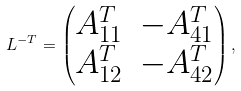Convert formula to latex. <formula><loc_0><loc_0><loc_500><loc_500>L ^ { - T } = \begin{pmatrix} A _ { 1 1 } ^ { T } & - A _ { 4 1 } ^ { T } \\ A _ { 1 2 } ^ { T } & - A _ { 4 2 } ^ { T } \end{pmatrix} ,</formula> 